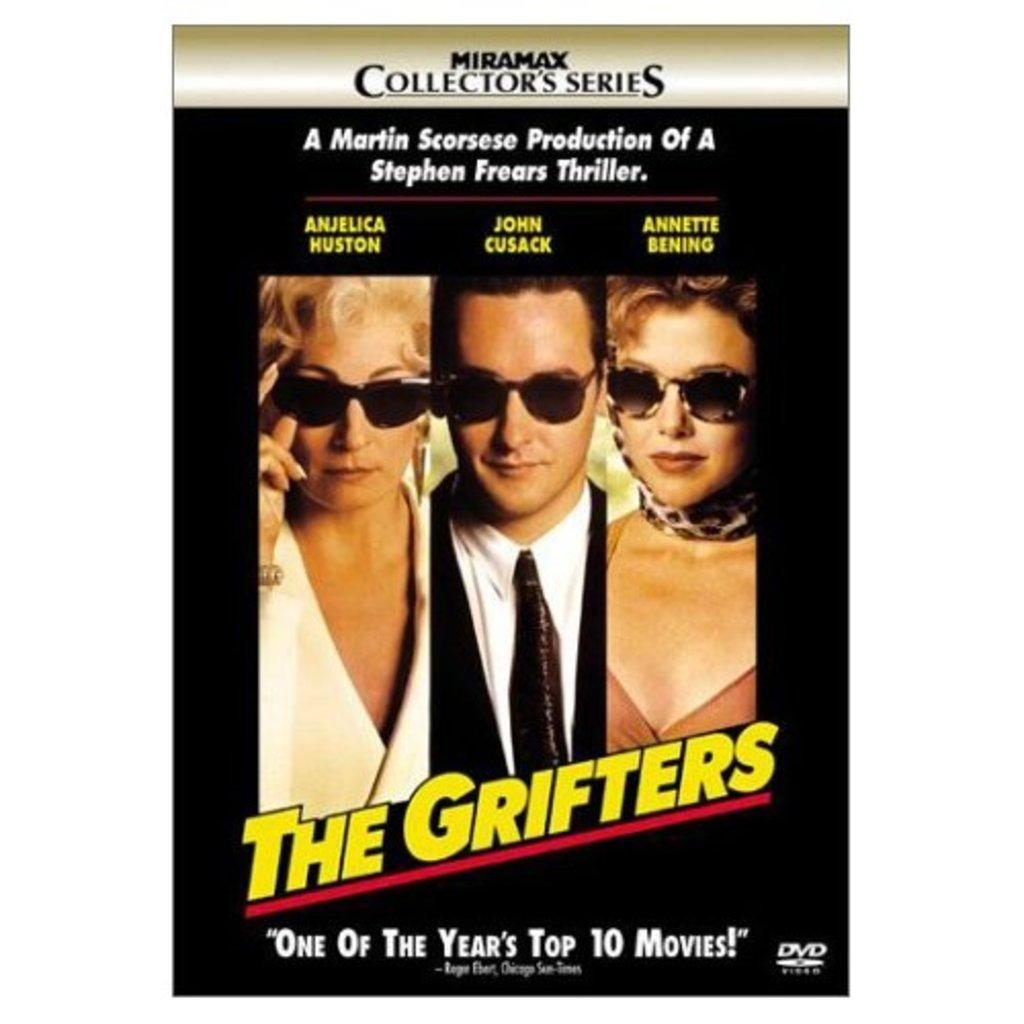What is present in the picture? There is a poster in the picture. What can be found on the poster? The poster contains pictures and text. Who is depicted on the poster? The poster features two women and a man. What are the individuals wearing in the poster? All three individuals are wearing goggles. Where is the playground located in the image? There is no playground present in the image; it features a poster with pictures and text. Can you tell me what type of camera the man is holding in the image? There is no camera visible in the image; the individuals are wearing goggles. 